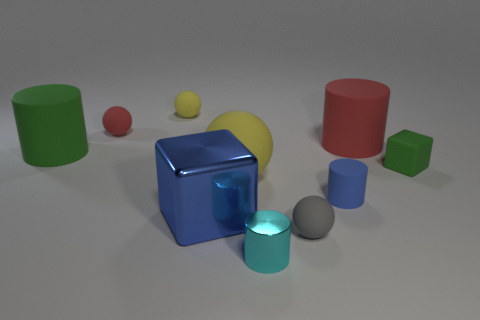Subtract all yellow cylinders. Subtract all green balls. How many cylinders are left? 4 Subtract all balls. How many objects are left? 6 Add 2 yellow objects. How many yellow objects are left? 4 Add 1 green matte blocks. How many green matte blocks exist? 2 Subtract 0 purple blocks. How many objects are left? 10 Subtract all shiny things. Subtract all big yellow metal objects. How many objects are left? 8 